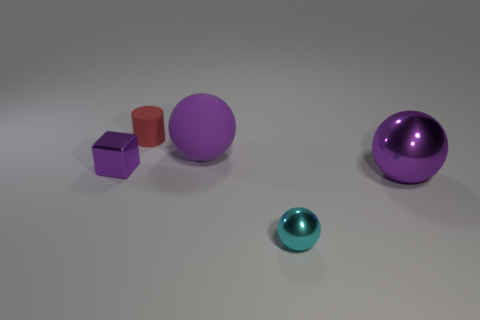Does the big rubber ball have the same color as the metallic ball that is left of the big purple metallic object?
Provide a succinct answer. No. Are there more red matte cylinders than objects?
Keep it short and to the point. No. What color is the big rubber thing?
Provide a succinct answer. Purple. Does the large sphere that is to the right of the big rubber thing have the same color as the small rubber cylinder?
Keep it short and to the point. No. There is a small thing that is the same color as the large matte thing; what is it made of?
Provide a short and direct response. Metal. How many big metallic balls have the same color as the tiny rubber cylinder?
Offer a terse response. 0. Is the shape of the tiny object on the left side of the tiny rubber object the same as  the large purple metal object?
Provide a succinct answer. No. Is the number of red objects on the right side of the red matte cylinder less than the number of big things on the right side of the small metallic sphere?
Ensure brevity in your answer.  Yes. What is the material of the big object that is in front of the big matte thing?
Provide a succinct answer. Metal. What size is the matte sphere that is the same color as the tiny shiny cube?
Ensure brevity in your answer.  Large. 